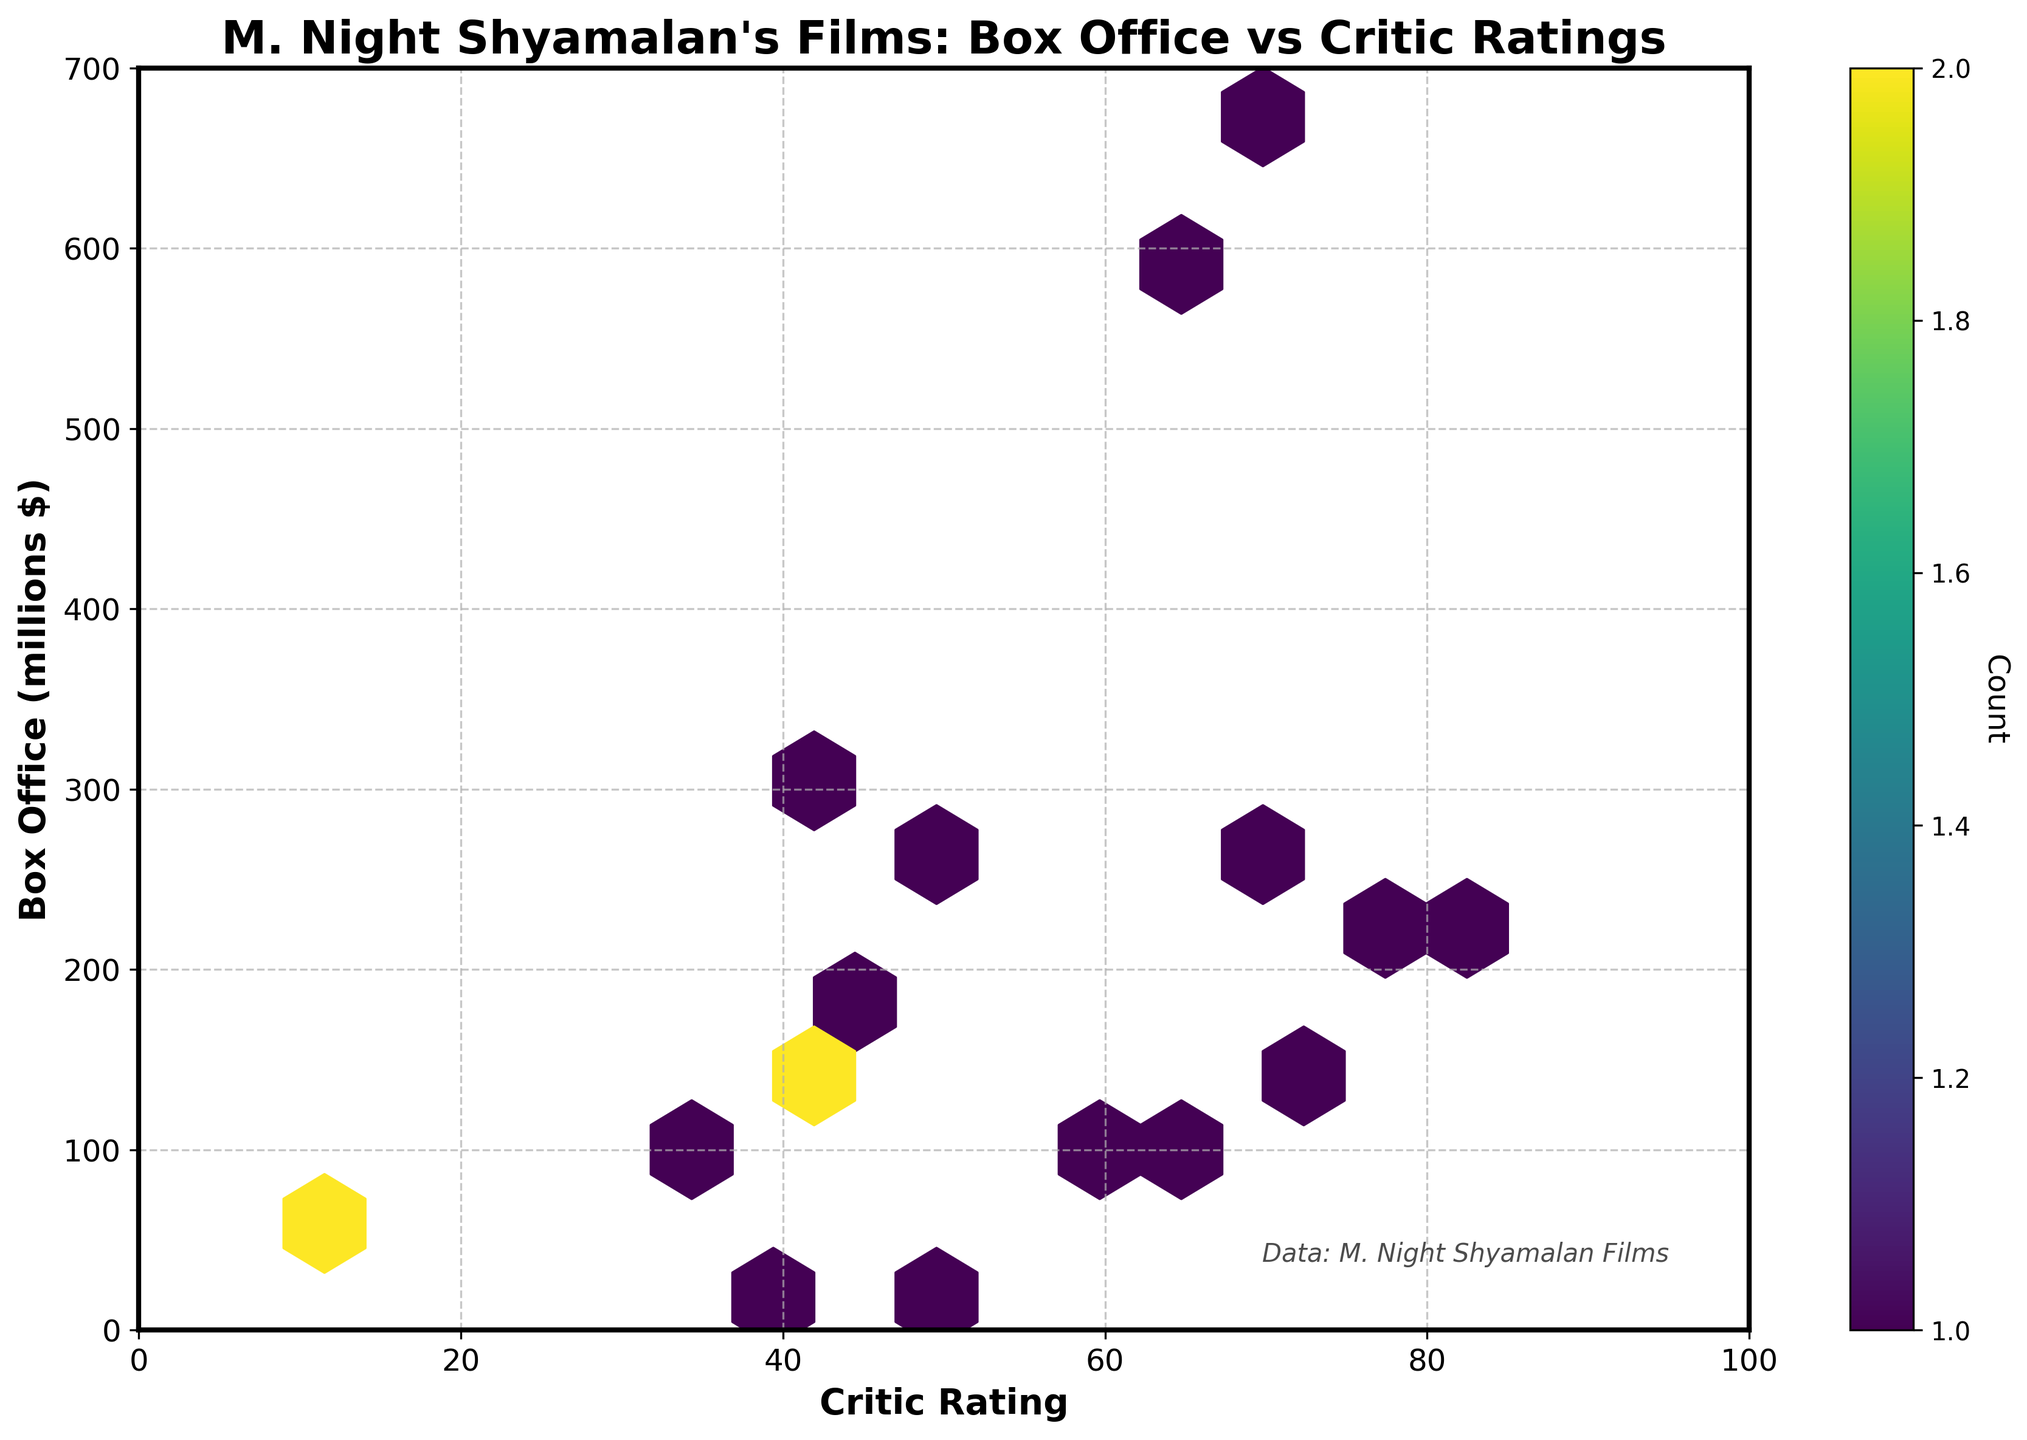What does the title of the figure indicate? The title of the figure provides an overview of what the plot illustrates. It indicates that the figure is about the relationship between the box office earnings and critic ratings of M. Night Shyamalan's films.
Answer: M. Night Shyamalan's Films: Box Office vs Critic Ratings What does the color intensity represent in this Hexbin Plot? The color intensity in the Hexbin Plot signifies the count of data points within each hexagonal bin. Darker colors indicate higher counts, while lighter colors signify fewer counts.
Answer: Count of data points What is the range of critic ratings shown on the x-axis? The x-axis of the plot, labeled 'Critic Rating,' ranges from a minimum value to a maximum value. The limits of this axis are easy to determine by looking at its labeled range.
Answer: 0 to 100 Which film has the highest box office earnings, and what is its critic rating? The highest box office earnings can be identified as the point located at the topmost position in the plot. By tracing the point horizontally to the x-axis, we can determine its critic rating.
Answer: 672.8 million, 68 critic rating How many data points fall within the hexbin cell located at the critic rating of 40 and box office earnings around 150-200 million? By locating the approximate position on the plot at 40 for critic rating and between 150-200 million for box office earnings, we can check the color intensity and refer to the color bar indicating the count.
Answer: 2 data points What appears to be the general trend between critic ratings and box office earnings? Observing the overall distribution of the hexagonal bins and their color intensities helps understand the trend's direction. Generally, if higher critic ratings correspond with higher box office earnings or vice versa, it suggests a particular trend.
Answer: No clear trend What is the default value shown in the color bar? The color bar, which indicates the count of data points, typically starts at a certain number. This number can be identified by inspecting the range and labels on the color bar.
Answer: 1 Are there more films with a critic rating above 60 or below 40? By inspecting the hexbin plot and counting the data points in the bins where critic ratings are above 60 versus those below 40, we can determine which range has more films.
Answer: Below 40 What critic rating ranges have the densest concentration of films? We can identify the ranges with the densest concentration by looking for regions in the hexbin plot where the hexagons are the darkest, as darker colors indicate higher counts of data points.
Answer: Around 60-70 and 30-40 How many films have a critic rating between 60 and 70 with box office earnings above 200 million? Locate the hexagonal bins within the x-axis range of 60-70 and filter further using the y-axis range of above 200 million to determine the number of films falling into these bins using color intensity for count.
Answer: 2 films 